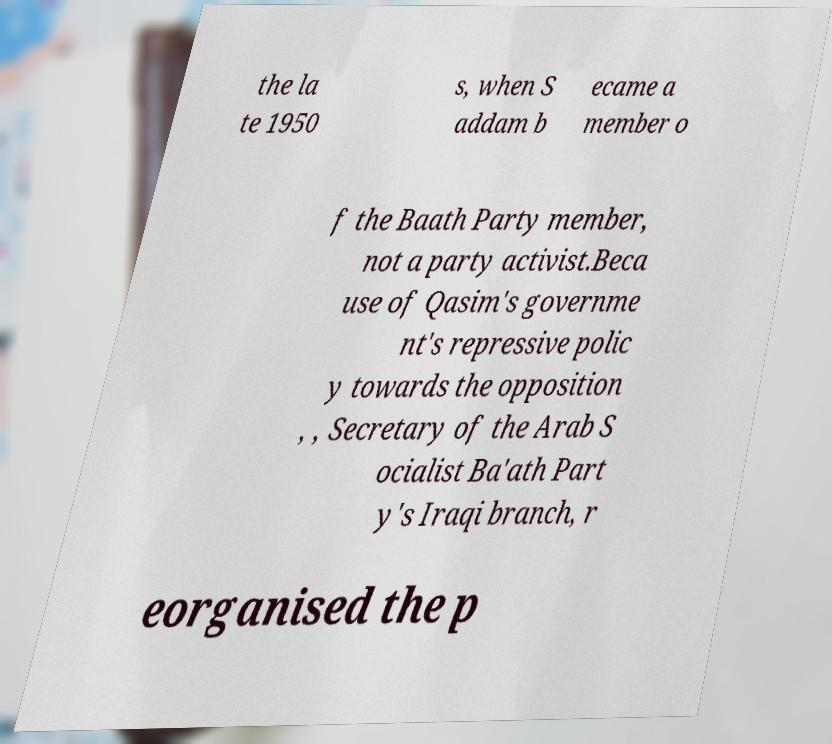Could you extract and type out the text from this image? the la te 1950 s, when S addam b ecame a member o f the Baath Party member, not a party activist.Beca use of Qasim's governme nt's repressive polic y towards the opposition , , Secretary of the Arab S ocialist Ba'ath Part y's Iraqi branch, r eorganised the p 